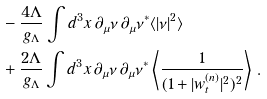<formula> <loc_0><loc_0><loc_500><loc_500>& - \frac { 4 \Lambda } { g _ { \Lambda } } \int d ^ { 3 } x \, \partial _ { \mu } \nu \, \partial _ { \mu } \nu ^ { * } \langle | \nu | ^ { 2 } \rangle \\ & + \frac { 2 \Lambda } { g _ { \Lambda } } \int d ^ { 3 } x \, \partial _ { \mu } \nu \, \partial _ { \mu } \nu ^ { * } \left \langle \frac { 1 } { ( 1 + | w _ { t } ^ { ( n ) } | ^ { 2 } ) ^ { 2 } } \right \rangle \, .</formula> 